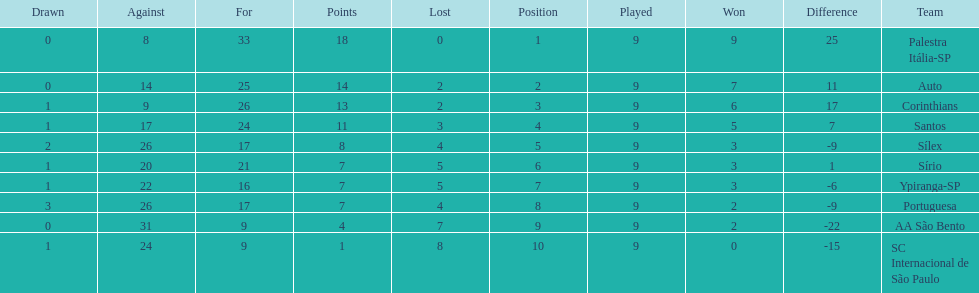In 1926 brazilian football,aside from the first place team, what other teams had winning records? Auto, Corinthians, Santos. 